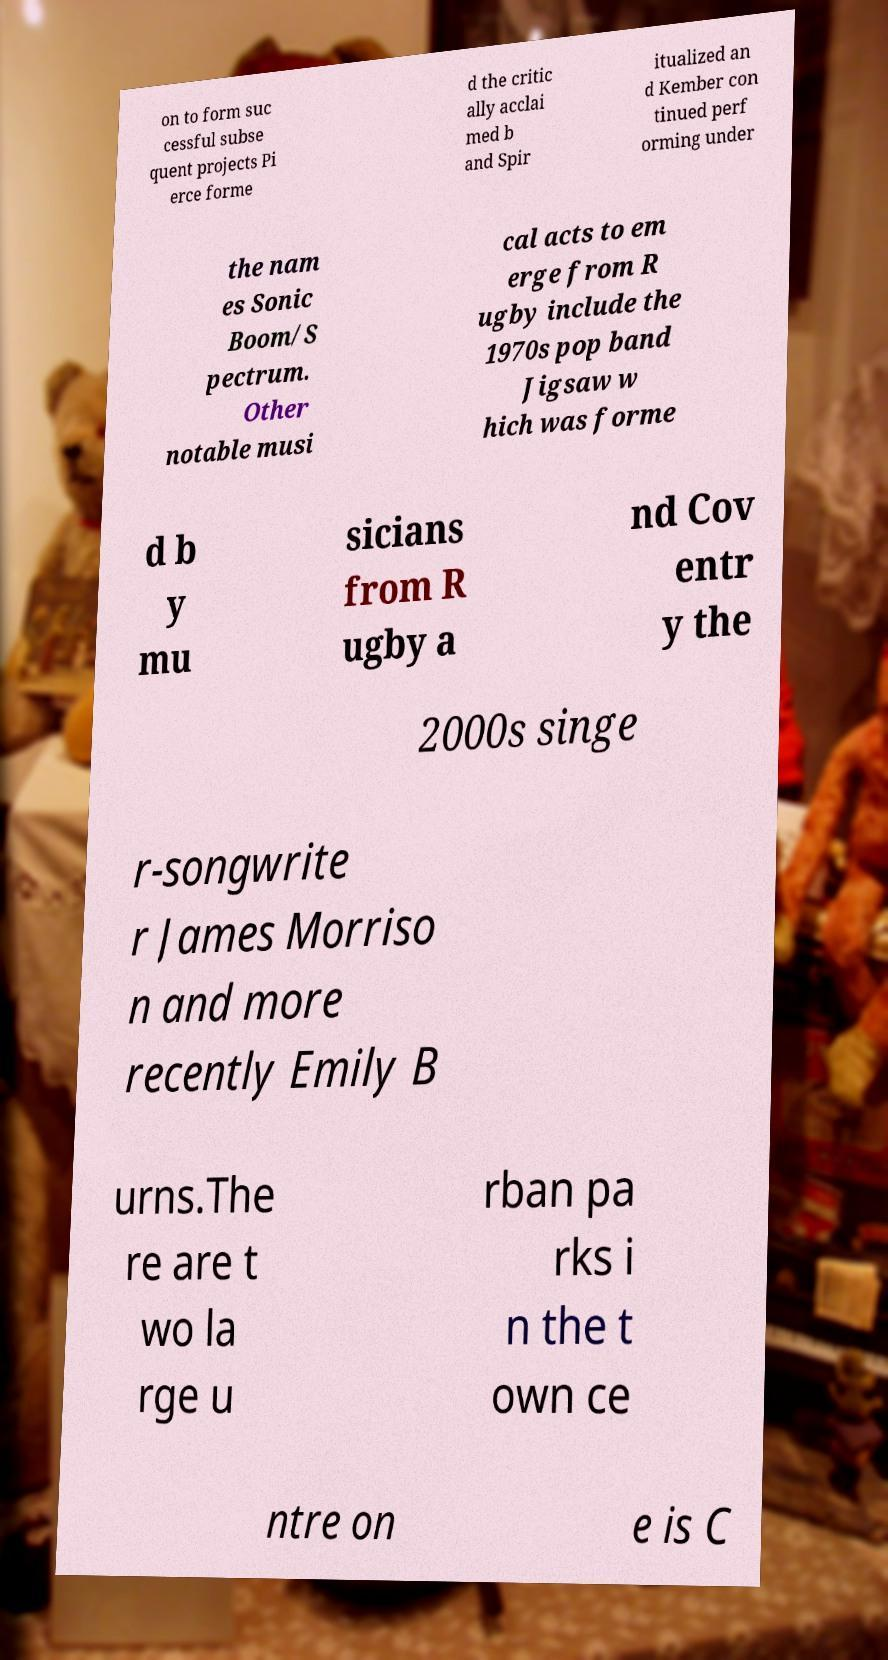Please read and relay the text visible in this image. What does it say? on to form suc cessful subse quent projects Pi erce forme d the critic ally acclai med b and Spir itualized an d Kember con tinued perf orming under the nam es Sonic Boom/S pectrum. Other notable musi cal acts to em erge from R ugby include the 1970s pop band Jigsaw w hich was forme d b y mu sicians from R ugby a nd Cov entr y the 2000s singe r-songwrite r James Morriso n and more recently Emily B urns.The re are t wo la rge u rban pa rks i n the t own ce ntre on e is C 